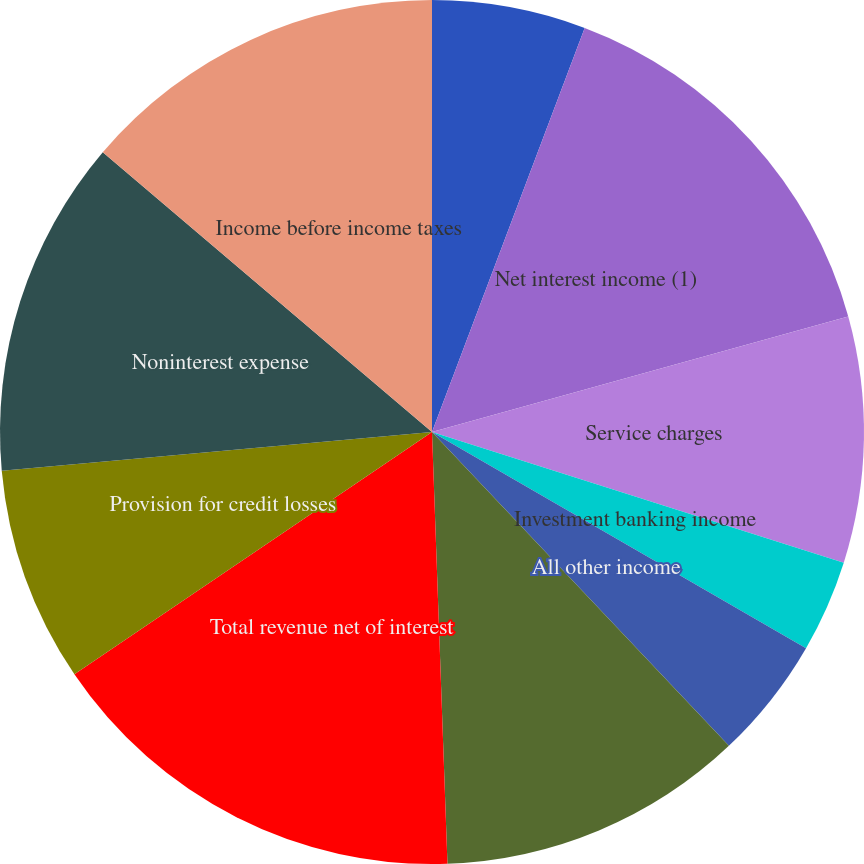<chart> <loc_0><loc_0><loc_500><loc_500><pie_chart><fcel>(Dollars in millions)<fcel>Net interest income (1)<fcel>Service charges<fcel>Investment banking income<fcel>All other income<fcel>Total noninterest income<fcel>Total revenue net of interest<fcel>Provision for credit losses<fcel>Noninterest expense<fcel>Income before income taxes<nl><fcel>5.75%<fcel>14.94%<fcel>9.2%<fcel>3.45%<fcel>4.6%<fcel>11.49%<fcel>16.09%<fcel>8.05%<fcel>12.64%<fcel>13.79%<nl></chart> 